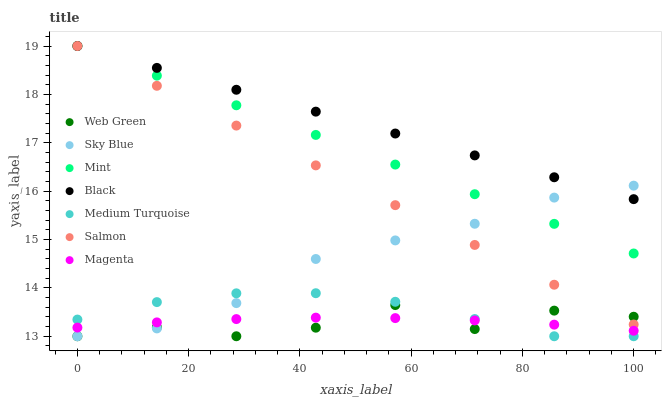Does Web Green have the minimum area under the curve?
Answer yes or no. Yes. Does Black have the maximum area under the curve?
Answer yes or no. Yes. Does Black have the minimum area under the curve?
Answer yes or no. No. Does Web Green have the maximum area under the curve?
Answer yes or no. No. Is Salmon the smoothest?
Answer yes or no. Yes. Is Web Green the roughest?
Answer yes or no. Yes. Is Black the smoothest?
Answer yes or no. No. Is Black the roughest?
Answer yes or no. No. Does Web Green have the lowest value?
Answer yes or no. Yes. Does Black have the lowest value?
Answer yes or no. No. Does Mint have the highest value?
Answer yes or no. Yes. Does Web Green have the highest value?
Answer yes or no. No. Is Medium Turquoise less than Mint?
Answer yes or no. Yes. Is Black greater than Magenta?
Answer yes or no. Yes. Does Black intersect Mint?
Answer yes or no. Yes. Is Black less than Mint?
Answer yes or no. No. Is Black greater than Mint?
Answer yes or no. No. Does Medium Turquoise intersect Mint?
Answer yes or no. No. 